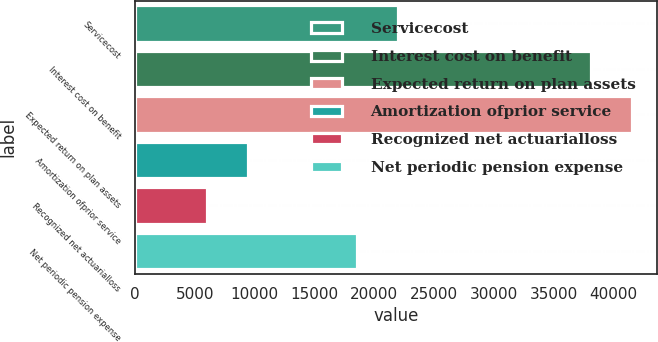Convert chart. <chart><loc_0><loc_0><loc_500><loc_500><bar_chart><fcel>Servicecost<fcel>Interest cost on benefit<fcel>Expected return on plan assets<fcel>Amortization ofprior service<fcel>Recognized net actuarialloss<fcel>Net periodic pension expense<nl><fcel>21955.9<fcel>38120<fcel>41535.9<fcel>9408.9<fcel>5993<fcel>18540<nl></chart> 